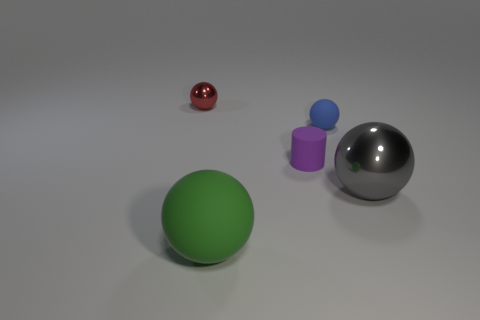What number of things are either large objects or balls in front of the tiny blue rubber sphere?
Offer a terse response. 2. Is the number of purple objects that are on the left side of the large gray ball greater than the number of gray objects to the left of the blue rubber sphere?
Offer a very short reply. Yes. There is a sphere behind the matte sphere behind the metallic thing in front of the tiny red shiny sphere; what is its material?
Your answer should be compact. Metal. The small purple thing that is made of the same material as the big green sphere is what shape?
Keep it short and to the point. Cylinder. There is a ball on the right side of the blue matte thing; is there a sphere on the left side of it?
Provide a short and direct response. Yes. The gray metal object is what size?
Give a very brief answer. Large. How many things are rubber balls or small cyan rubber balls?
Offer a terse response. 2. Is the thing in front of the big shiny sphere made of the same material as the thing on the right side of the tiny matte sphere?
Make the answer very short. No. What is the color of the ball that is the same material as the gray thing?
Your answer should be very brief. Red. How many other spheres are the same size as the blue sphere?
Your response must be concise. 1. 